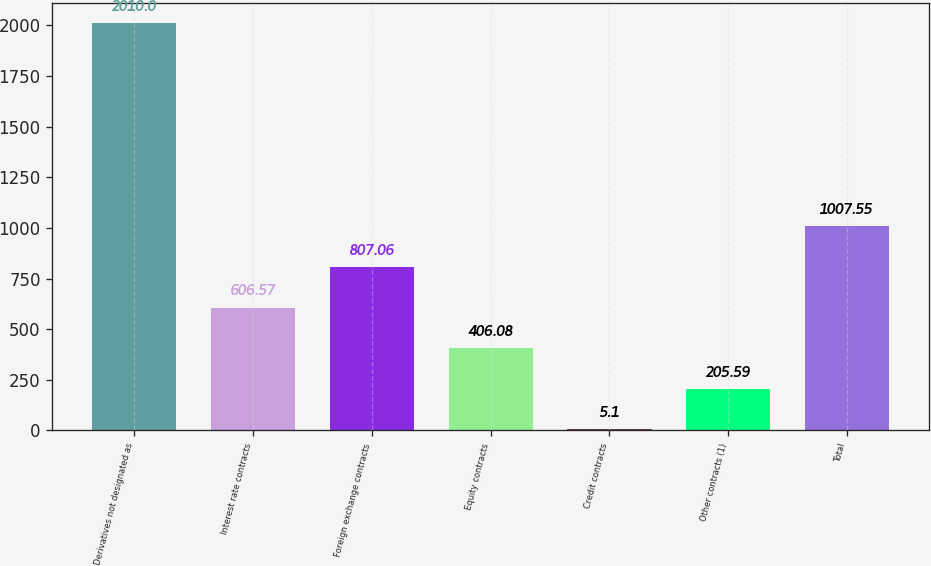Convert chart to OTSL. <chart><loc_0><loc_0><loc_500><loc_500><bar_chart><fcel>Derivatives not designated as<fcel>Interest rate contracts<fcel>Foreign exchange contracts<fcel>Equity contracts<fcel>Credit contracts<fcel>Other contracts (1)<fcel>Total<nl><fcel>2010<fcel>606.57<fcel>807.06<fcel>406.08<fcel>5.1<fcel>205.59<fcel>1007.55<nl></chart> 